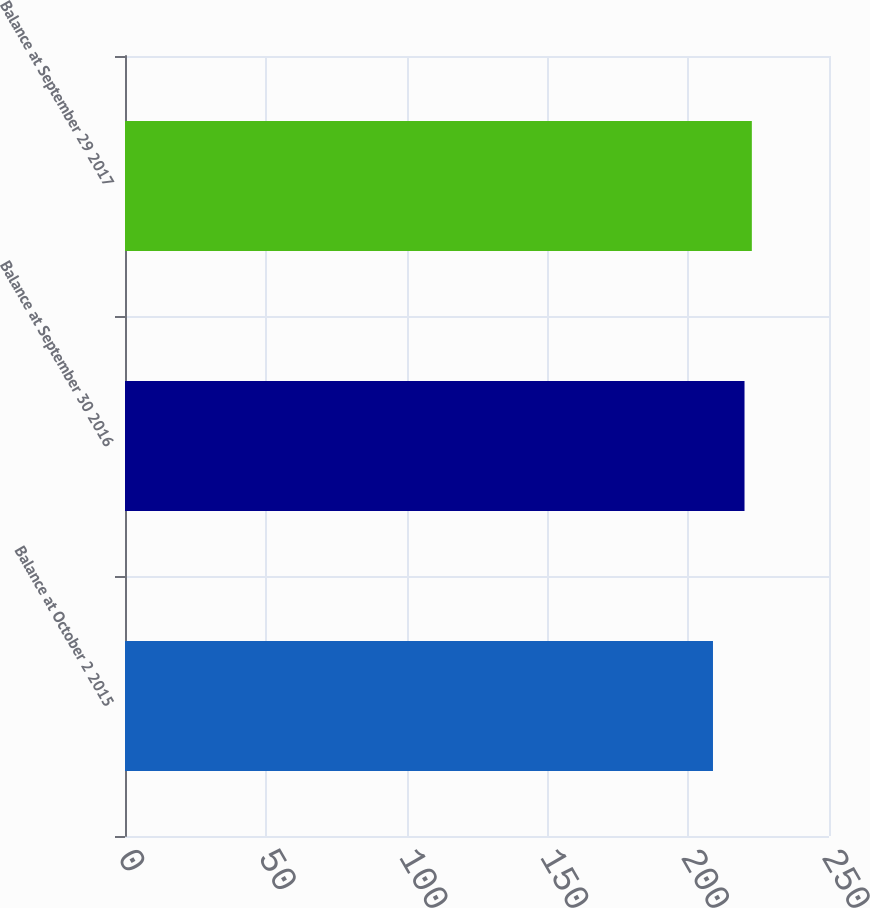<chart> <loc_0><loc_0><loc_500><loc_500><bar_chart><fcel>Balance at October 2 2015<fcel>Balance at September 30 2016<fcel>Balance at September 29 2017<nl><fcel>208.8<fcel>220<fcel>222.6<nl></chart> 